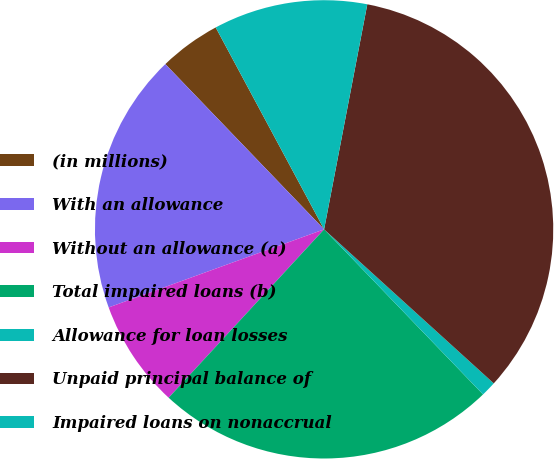Convert chart to OTSL. <chart><loc_0><loc_0><loc_500><loc_500><pie_chart><fcel>(in millions)<fcel>With an allowance<fcel>Without an allowance (a)<fcel>Total impaired loans (b)<fcel>Allowance for loan losses<fcel>Unpaid principal balance of<fcel>Impaired loans on nonaccrual<nl><fcel>4.34%<fcel>18.35%<fcel>7.6%<fcel>24.06%<fcel>1.07%<fcel>33.71%<fcel>10.86%<nl></chart> 